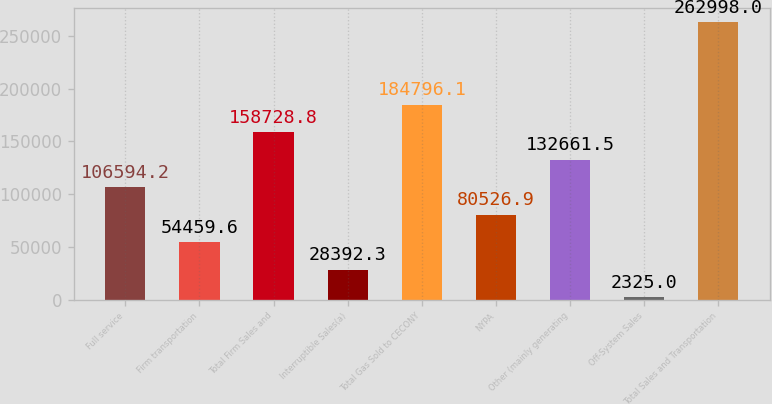Convert chart. <chart><loc_0><loc_0><loc_500><loc_500><bar_chart><fcel>Full service<fcel>Firm transportation<fcel>Total Firm Sales and<fcel>Interruptible Sales(a)<fcel>Total Gas Sold to CECONY<fcel>NYPA<fcel>Other (mainly generating<fcel>Off-System Sales<fcel>Total Sales and Transportation<nl><fcel>106594<fcel>54459.6<fcel>158729<fcel>28392.3<fcel>184796<fcel>80526.9<fcel>132662<fcel>2325<fcel>262998<nl></chart> 